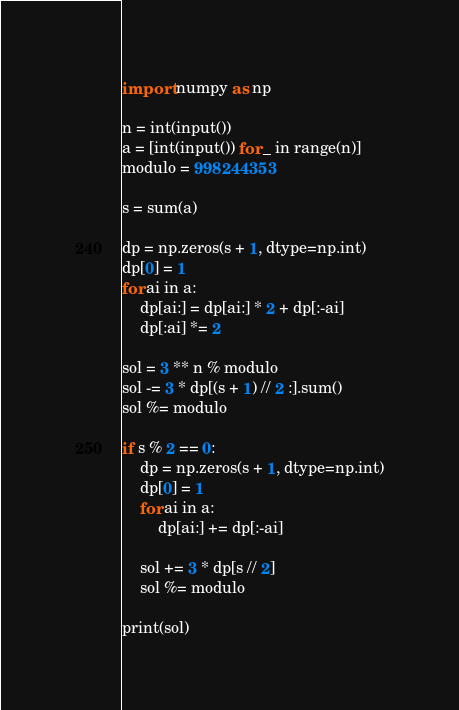Convert code to text. <code><loc_0><loc_0><loc_500><loc_500><_Python_>import numpy as np

n = int(input())
a = [int(input()) for _ in range(n)]
modulo = 998244353

s = sum(a)

dp = np.zeros(s + 1, dtype=np.int)
dp[0] = 1
for ai in a:
    dp[ai:] = dp[ai:] * 2 + dp[:-ai]
    dp[:ai] *= 2

sol = 3 ** n % modulo
sol -= 3 * dp[(s + 1) // 2 :].sum()
sol %= modulo

if s % 2 == 0:
    dp = np.zeros(s + 1, dtype=np.int)
    dp[0] = 1
    for ai in a:
        dp[ai:] += dp[:-ai]

    sol += 3 * dp[s // 2]
    sol %= modulo

print(sol)
</code> 